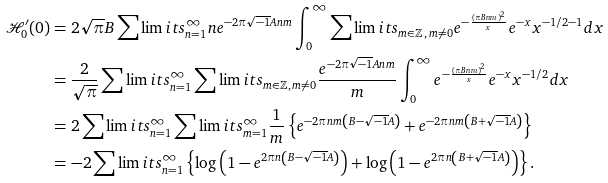<formula> <loc_0><loc_0><loc_500><loc_500>\mathcal { H } _ { 0 } ^ { \prime } ( 0 ) & = 2 \sqrt { \pi } B \sum \lim i t s _ { n = 1 } ^ { \infty } n e ^ { - 2 \pi \sqrt { - 1 } A n m } \int _ { 0 } ^ { \infty } \sum \lim i t s _ { m \in \mathbb { Z } \, , \, m \not = 0 } e ^ { - \frac { \left ( \pi B n m \right ) ^ { 2 } } { x } } e ^ { - x } x ^ { - 1 / 2 - 1 } d x \\ & = \frac { 2 } { \sqrt { \pi } } \sum \lim i t s _ { n = 1 } ^ { \infty } \sum \lim i t s _ { m \in \mathbb { Z } , \, m \not = 0 } \frac { e ^ { - 2 \pi \sqrt { - 1 } A n m } } { m } \int _ { 0 } ^ { \infty } e ^ { - \frac { \left ( \pi B n m \right ) ^ { 2 } } { x } } e ^ { - x } x ^ { - 1 / 2 } d x \\ & = 2 \sum \lim i t s _ { n = 1 } ^ { \infty } \sum \lim i t s _ { m = 1 } ^ { \infty } \frac { 1 } { m } \left \{ e ^ { - 2 \pi n m \left ( B - \sqrt { - 1 } A \right ) } + e ^ { - 2 \pi n m \left ( B + \sqrt { - 1 } A \right ) } \right \} \\ & = - 2 \sum \lim i t s _ { n = 1 } ^ { \infty } \left \{ \log \left ( 1 - e ^ { 2 \pi n \left ( B - \sqrt { - 1 } A \right ) } \right ) + \log \left ( 1 - e ^ { 2 \pi n \left ( B + \sqrt { - 1 } A \right ) } \right ) \right \} .</formula> 